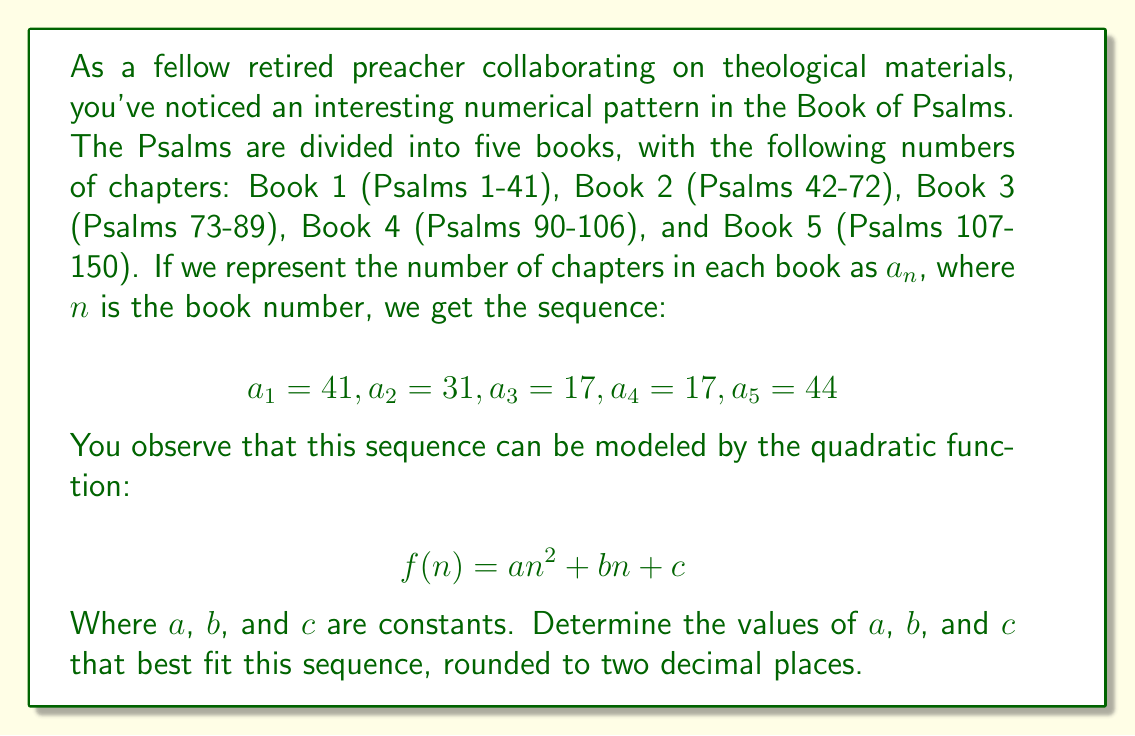Give your solution to this math problem. To solve this problem, we need to use the method of least squares to find the best-fitting quadratic function. Here are the steps:

1) First, we set up a system of normal equations:

   $$\sum y = 5c + b\sum x + a\sum x^2$$
   $$\sum xy = c\sum x + b\sum x^2 + a\sum x^3$$
   $$\sum x^2y = c\sum x^2 + b\sum x^3 + a\sum x^4$$

2) We need to calculate the following sums:

   $\sum x = 1 + 2 + 3 + 4 + 5 = 15$
   $\sum x^2 = 1^2 + 2^2 + 3^2 + 4^2 + 5^2 = 55$
   $\sum x^3 = 1^3 + 2^3 + 3^3 + 4^3 + 5^3 = 225$
   $\sum x^4 = 1^4 + 2^4 + 3^4 + 4^4 + 5^4 = 979$
   $\sum y = 41 + 31 + 17 + 17 + 44 = 150$
   $\sum xy = 1(41) + 2(31) + 3(17) + 4(17) + 5(44) = 516$
   $\sum x^2y = 1^2(41) + 2^2(31) + 3^2(17) + 4^2(17) + 5^2(44) = 2014$

3) Now we can set up our system of equations:

   $$150 = 5c + 15b + 55a$$
   $$516 = 15c + 55b + 225a$$
   $$2014 = 55c + 225b + 979a$$

4) Solving this system of equations (using a computer algebra system or matrix operations) gives us:

   $a \approx 3.6571$
   $b \approx -23.8286$
   $c \approx 61.1714$

5) Rounding to two decimal places:

   $a \approx 3.66$
   $b \approx -23.83$
   $c \approx 61.17$

Therefore, the best-fitting quadratic function is:

$f(n) \approx 3.66n^2 - 23.83n + 61.17$
Answer: $a \approx 3.66$, $b \approx -23.83$, $c \approx 61.17$ 